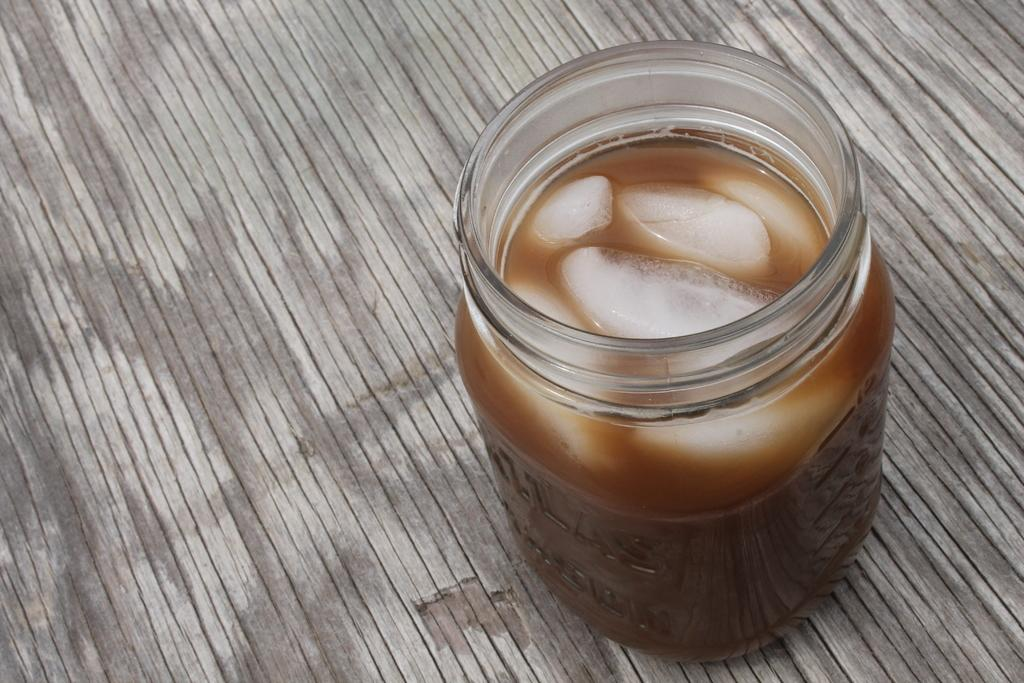What is the main object in the image? There is a jar in the image. What is inside the jar? There are ice pieces in the jar. Is there anything else in the jar besides the ice pieces? Yes, there is a brown-colored object in the jar. What type of fiction book is the train carrying in the image? There is no train or fiction book present in the image. The image only contains a jar with ice pieces and a brown-colored object. 